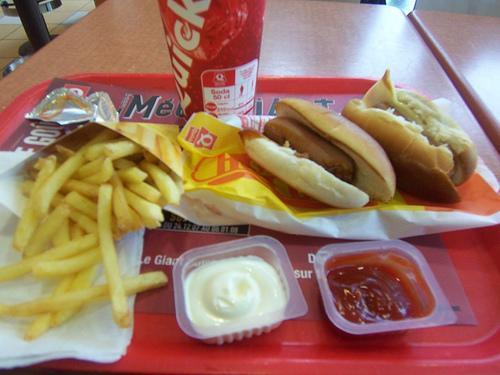How many hot dogs are there?
Give a very brief answer. 2. How many dining tables are there?
Give a very brief answer. 2. How many hot dogs can be seen?
Give a very brief answer. 2. How many vases are there?
Give a very brief answer. 0. 